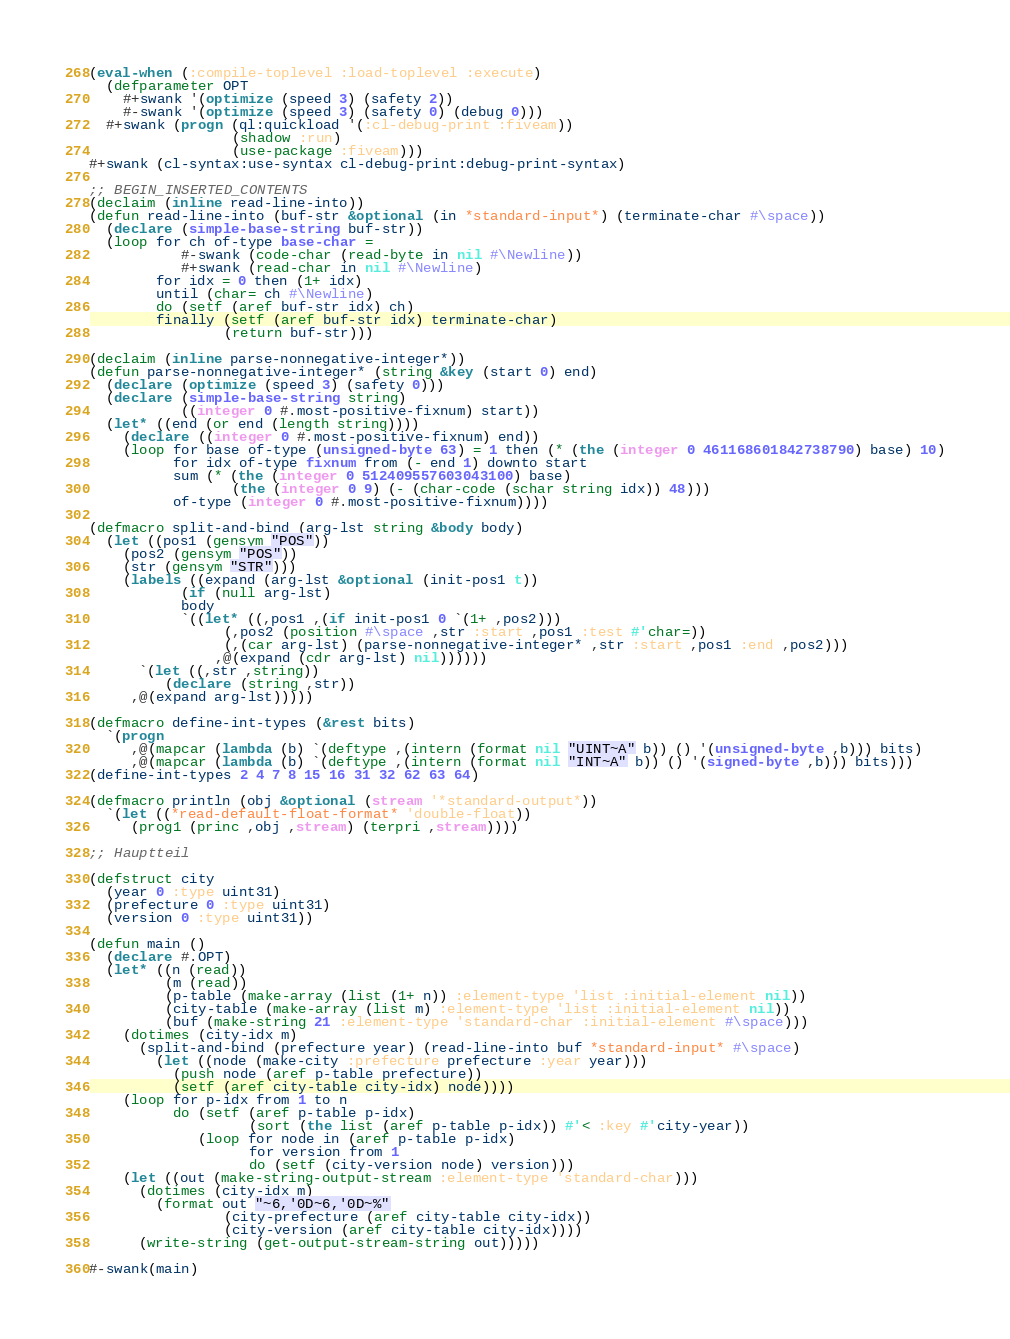Convert code to text. <code><loc_0><loc_0><loc_500><loc_500><_Lisp_>(eval-when (:compile-toplevel :load-toplevel :execute)
  (defparameter OPT
    #+swank '(optimize (speed 3) (safety 2))
    #-swank '(optimize (speed 3) (safety 0) (debug 0)))
  #+swank (progn (ql:quickload '(:cl-debug-print :fiveam))
                 (shadow :run)
                 (use-package :fiveam)))
#+swank (cl-syntax:use-syntax cl-debug-print:debug-print-syntax)

;; BEGIN_INSERTED_CONTENTS
(declaim (inline read-line-into))
(defun read-line-into (buf-str &optional (in *standard-input*) (terminate-char #\space))
  (declare (simple-base-string buf-str))
  (loop for ch of-type base-char =
           #-swank (code-char (read-byte in nil #\Newline))
           #+swank (read-char in nil #\Newline)
        for idx = 0 then (1+ idx)
        until (char= ch #\Newline)
        do (setf (aref buf-str idx) ch)
        finally (setf (aref buf-str idx) terminate-char)
                (return buf-str)))

(declaim (inline parse-nonnegative-integer*))
(defun parse-nonnegative-integer* (string &key (start 0) end)
  (declare (optimize (speed 3) (safety 0)))
  (declare (simple-base-string string)
           ((integer 0 #.most-positive-fixnum) start))
  (let* ((end (or end (length string))))
    (declare ((integer 0 #.most-positive-fixnum) end))
    (loop for base of-type (unsigned-byte 63) = 1 then (* (the (integer 0 461168601842738790) base) 10)
          for idx of-type fixnum from (- end 1) downto start
          sum (* (the (integer 0 512409557603043100) base)
                 (the (integer 0 9) (- (char-code (schar string idx)) 48)))
          of-type (integer 0 #.most-positive-fixnum))))

(defmacro split-and-bind (arg-lst string &body body)
  (let ((pos1 (gensym "POS"))
	(pos2 (gensym "POS"))
	(str (gensym "STR")))
    (labels ((expand (arg-lst &optional (init-pos1 t))
	       (if (null arg-lst)
		   body
		   `((let* ((,pos1 ,(if init-pos1 0 `(1+ ,pos2)))
			    (,pos2 (position #\space ,str :start ,pos1 :test #'char=))
			    (,(car arg-lst) (parse-nonnegative-integer* ,str :start ,pos1 :end ,pos2)))
		       ,@(expand (cdr arg-lst) nil))))))
      `(let ((,str ,string))
         (declare (string ,str))
	 ,@(expand arg-lst)))))

(defmacro define-int-types (&rest bits)
  `(progn
     ,@(mapcar (lambda (b) `(deftype ,(intern (format nil "UINT~A" b)) () '(unsigned-byte ,b))) bits)
     ,@(mapcar (lambda (b) `(deftype ,(intern (format nil "INT~A" b)) () '(signed-byte ,b))) bits)))
(define-int-types 2 4 7 8 15 16 31 32 62 63 64)

(defmacro println (obj &optional (stream '*standard-output*))
  `(let ((*read-default-float-format* 'double-float))
     (prog1 (princ ,obj ,stream) (terpri ,stream))))

;; Hauptteil

(defstruct city
  (year 0 :type uint31)
  (prefecture 0 :type uint31)
  (version 0 :type uint31))

(defun main ()
  (declare #.OPT)
  (let* ((n (read))
         (m (read))
         (p-table (make-array (list (1+ n)) :element-type 'list :initial-element nil))
         (city-table (make-array (list m) :element-type 'list :initial-element nil))
         (buf (make-string 21 :element-type 'standard-char :initial-element #\space)))
    (dotimes (city-idx m)
      (split-and-bind (prefecture year) (read-line-into buf *standard-input* #\space)
        (let ((node (make-city :prefecture prefecture :year year)))
          (push node (aref p-table prefecture))
          (setf (aref city-table city-idx) node))))
    (loop for p-idx from 1 to n
          do (setf (aref p-table p-idx)
                   (sort (the list (aref p-table p-idx)) #'< :key #'city-year))
             (loop for node in (aref p-table p-idx)
                   for version from 1
                   do (setf (city-version node) version)))
    (let ((out (make-string-output-stream :element-type 'standard-char)))
      (dotimes (city-idx m)
        (format out "~6,'0D~6,'0D~%"
                (city-prefecture (aref city-table city-idx))
                (city-version (aref city-table city-idx))))
      (write-string (get-output-stream-string out)))))

#-swank(main)
</code> 